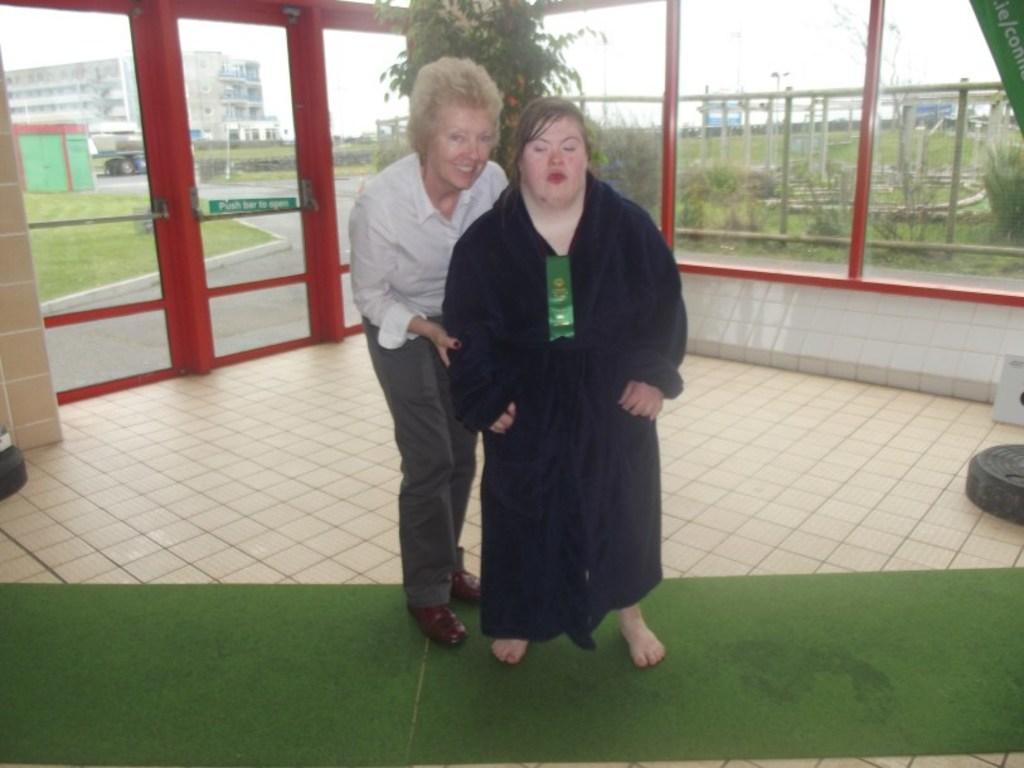Could you give a brief overview of what you see in this image? In the middle a woman is standing, she wore black color dress, beside her another woman is smiling, she wore white color shirt. Behind them there is a plant and glass wall. 